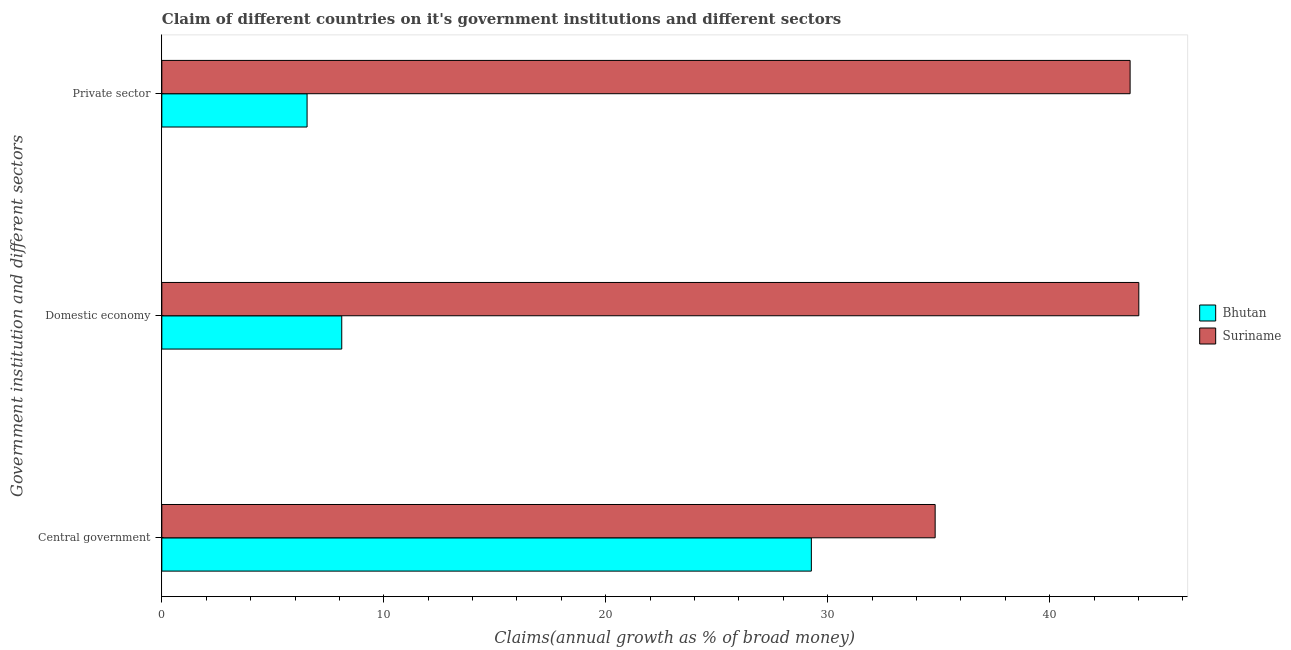How many different coloured bars are there?
Provide a succinct answer. 2. Are the number of bars on each tick of the Y-axis equal?
Ensure brevity in your answer.  Yes. How many bars are there on the 3rd tick from the top?
Give a very brief answer. 2. What is the label of the 3rd group of bars from the top?
Your answer should be very brief. Central government. What is the percentage of claim on the private sector in Suriname?
Your response must be concise. 43.63. Across all countries, what is the maximum percentage of claim on the central government?
Your answer should be compact. 34.84. Across all countries, what is the minimum percentage of claim on the domestic economy?
Keep it short and to the point. 8.11. In which country was the percentage of claim on the private sector maximum?
Give a very brief answer. Suriname. In which country was the percentage of claim on the domestic economy minimum?
Your answer should be compact. Bhutan. What is the total percentage of claim on the domestic economy in the graph?
Provide a succinct answer. 52.13. What is the difference between the percentage of claim on the private sector in Suriname and that in Bhutan?
Provide a short and direct response. 37.08. What is the difference between the percentage of claim on the central government in Suriname and the percentage of claim on the domestic economy in Bhutan?
Offer a terse response. 26.74. What is the average percentage of claim on the private sector per country?
Your response must be concise. 25.09. What is the difference between the percentage of claim on the central government and percentage of claim on the private sector in Bhutan?
Provide a succinct answer. 22.72. What is the ratio of the percentage of claim on the private sector in Bhutan to that in Suriname?
Keep it short and to the point. 0.15. Is the percentage of claim on the central government in Suriname less than that in Bhutan?
Your response must be concise. No. What is the difference between the highest and the second highest percentage of claim on the central government?
Your response must be concise. 5.58. What is the difference between the highest and the lowest percentage of claim on the central government?
Make the answer very short. 5.58. Is the sum of the percentage of claim on the central government in Bhutan and Suriname greater than the maximum percentage of claim on the domestic economy across all countries?
Keep it short and to the point. Yes. What does the 1st bar from the top in Domestic economy represents?
Your answer should be very brief. Suriname. What does the 1st bar from the bottom in Private sector represents?
Provide a succinct answer. Bhutan. Are all the bars in the graph horizontal?
Give a very brief answer. Yes. Are the values on the major ticks of X-axis written in scientific E-notation?
Ensure brevity in your answer.  No. Does the graph contain any zero values?
Give a very brief answer. No. Does the graph contain grids?
Your answer should be very brief. No. How many legend labels are there?
Give a very brief answer. 2. How are the legend labels stacked?
Offer a terse response. Vertical. What is the title of the graph?
Make the answer very short. Claim of different countries on it's government institutions and different sectors. Does "Mexico" appear as one of the legend labels in the graph?
Offer a terse response. No. What is the label or title of the X-axis?
Keep it short and to the point. Claims(annual growth as % of broad money). What is the label or title of the Y-axis?
Your answer should be compact. Government institution and different sectors. What is the Claims(annual growth as % of broad money) of Bhutan in Central government?
Provide a short and direct response. 29.27. What is the Claims(annual growth as % of broad money) of Suriname in Central government?
Your answer should be very brief. 34.84. What is the Claims(annual growth as % of broad money) in Bhutan in Domestic economy?
Your answer should be compact. 8.11. What is the Claims(annual growth as % of broad money) in Suriname in Domestic economy?
Give a very brief answer. 44.02. What is the Claims(annual growth as % of broad money) of Bhutan in Private sector?
Offer a terse response. 6.54. What is the Claims(annual growth as % of broad money) of Suriname in Private sector?
Provide a short and direct response. 43.63. Across all Government institution and different sectors, what is the maximum Claims(annual growth as % of broad money) in Bhutan?
Your answer should be compact. 29.27. Across all Government institution and different sectors, what is the maximum Claims(annual growth as % of broad money) in Suriname?
Provide a succinct answer. 44.02. Across all Government institution and different sectors, what is the minimum Claims(annual growth as % of broad money) of Bhutan?
Make the answer very short. 6.54. Across all Government institution and different sectors, what is the minimum Claims(annual growth as % of broad money) of Suriname?
Offer a terse response. 34.84. What is the total Claims(annual growth as % of broad money) of Bhutan in the graph?
Your answer should be very brief. 43.92. What is the total Claims(annual growth as % of broad money) of Suriname in the graph?
Provide a short and direct response. 122.49. What is the difference between the Claims(annual growth as % of broad money) in Bhutan in Central government and that in Domestic economy?
Make the answer very short. 21.16. What is the difference between the Claims(annual growth as % of broad money) in Suriname in Central government and that in Domestic economy?
Offer a terse response. -9.18. What is the difference between the Claims(annual growth as % of broad money) in Bhutan in Central government and that in Private sector?
Offer a terse response. 22.72. What is the difference between the Claims(annual growth as % of broad money) of Suriname in Central government and that in Private sector?
Make the answer very short. -8.78. What is the difference between the Claims(annual growth as % of broad money) of Bhutan in Domestic economy and that in Private sector?
Keep it short and to the point. 1.56. What is the difference between the Claims(annual growth as % of broad money) of Suriname in Domestic economy and that in Private sector?
Your answer should be compact. 0.39. What is the difference between the Claims(annual growth as % of broad money) in Bhutan in Central government and the Claims(annual growth as % of broad money) in Suriname in Domestic economy?
Provide a short and direct response. -14.75. What is the difference between the Claims(annual growth as % of broad money) of Bhutan in Central government and the Claims(annual growth as % of broad money) of Suriname in Private sector?
Ensure brevity in your answer.  -14.36. What is the difference between the Claims(annual growth as % of broad money) of Bhutan in Domestic economy and the Claims(annual growth as % of broad money) of Suriname in Private sector?
Provide a short and direct response. -35.52. What is the average Claims(annual growth as % of broad money) of Bhutan per Government institution and different sectors?
Offer a very short reply. 14.64. What is the average Claims(annual growth as % of broad money) of Suriname per Government institution and different sectors?
Ensure brevity in your answer.  40.83. What is the difference between the Claims(annual growth as % of broad money) in Bhutan and Claims(annual growth as % of broad money) in Suriname in Central government?
Offer a very short reply. -5.58. What is the difference between the Claims(annual growth as % of broad money) of Bhutan and Claims(annual growth as % of broad money) of Suriname in Domestic economy?
Keep it short and to the point. -35.91. What is the difference between the Claims(annual growth as % of broad money) of Bhutan and Claims(annual growth as % of broad money) of Suriname in Private sector?
Provide a succinct answer. -37.08. What is the ratio of the Claims(annual growth as % of broad money) of Bhutan in Central government to that in Domestic economy?
Make the answer very short. 3.61. What is the ratio of the Claims(annual growth as % of broad money) in Suriname in Central government to that in Domestic economy?
Offer a very short reply. 0.79. What is the ratio of the Claims(annual growth as % of broad money) of Bhutan in Central government to that in Private sector?
Offer a terse response. 4.47. What is the ratio of the Claims(annual growth as % of broad money) of Suriname in Central government to that in Private sector?
Give a very brief answer. 0.8. What is the ratio of the Claims(annual growth as % of broad money) of Bhutan in Domestic economy to that in Private sector?
Your answer should be compact. 1.24. What is the difference between the highest and the second highest Claims(annual growth as % of broad money) of Bhutan?
Make the answer very short. 21.16. What is the difference between the highest and the second highest Claims(annual growth as % of broad money) in Suriname?
Make the answer very short. 0.39. What is the difference between the highest and the lowest Claims(annual growth as % of broad money) of Bhutan?
Offer a very short reply. 22.72. What is the difference between the highest and the lowest Claims(annual growth as % of broad money) of Suriname?
Make the answer very short. 9.18. 